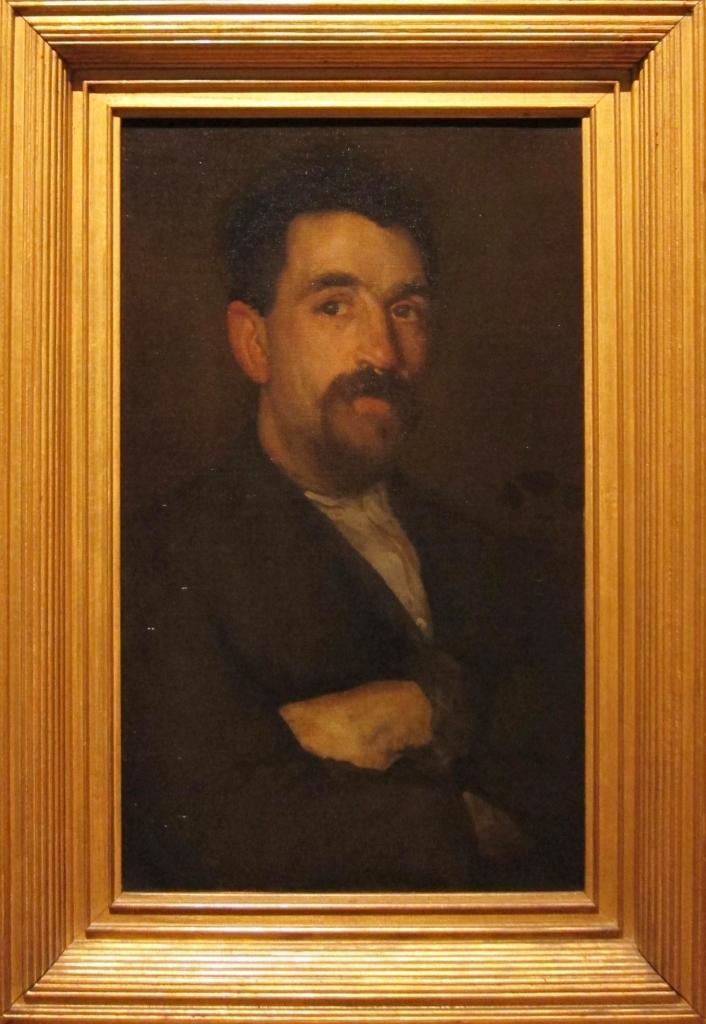Could you give a brief overview of what you see in this image? In this image we can see a photo frame and a picture of man in it. 